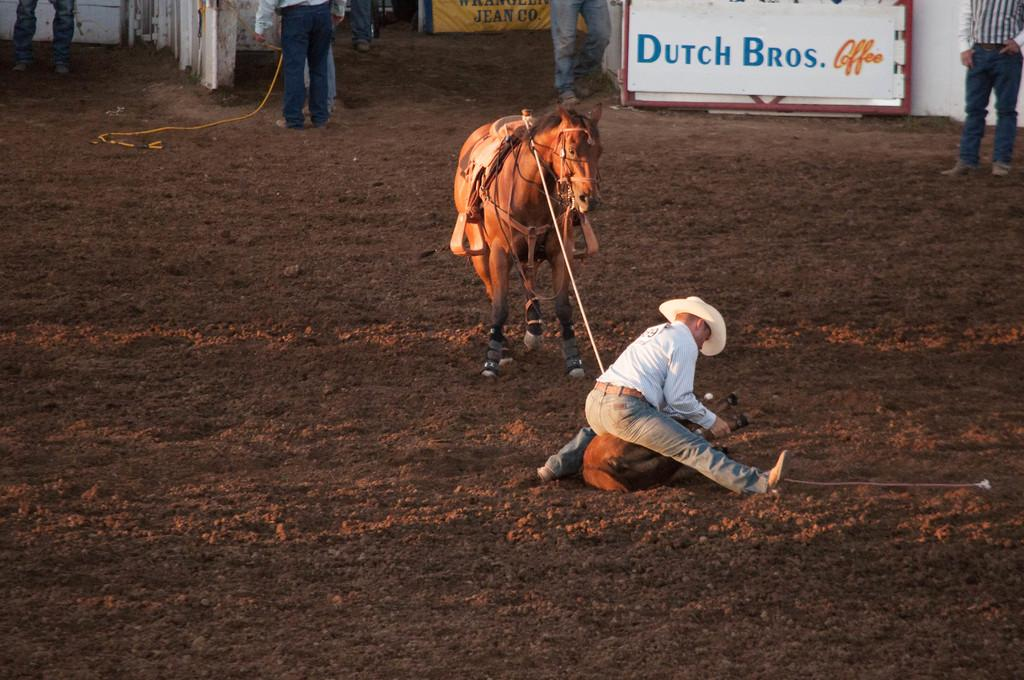What is the position of the person in the image? There is a person sitting on the ground in the image. What is the person holding in the image? The person is holding a rope of an animal. Are there any other people in the image? Yes, there are other persons standing in the image. What can be seen on the board in the image? There is a board with text in the image. How does the image demonstrate the acoustics of the environment? The image does not demonstrate the acoustics of the environment, as it focuses on the person, the animal, and the board with text. 